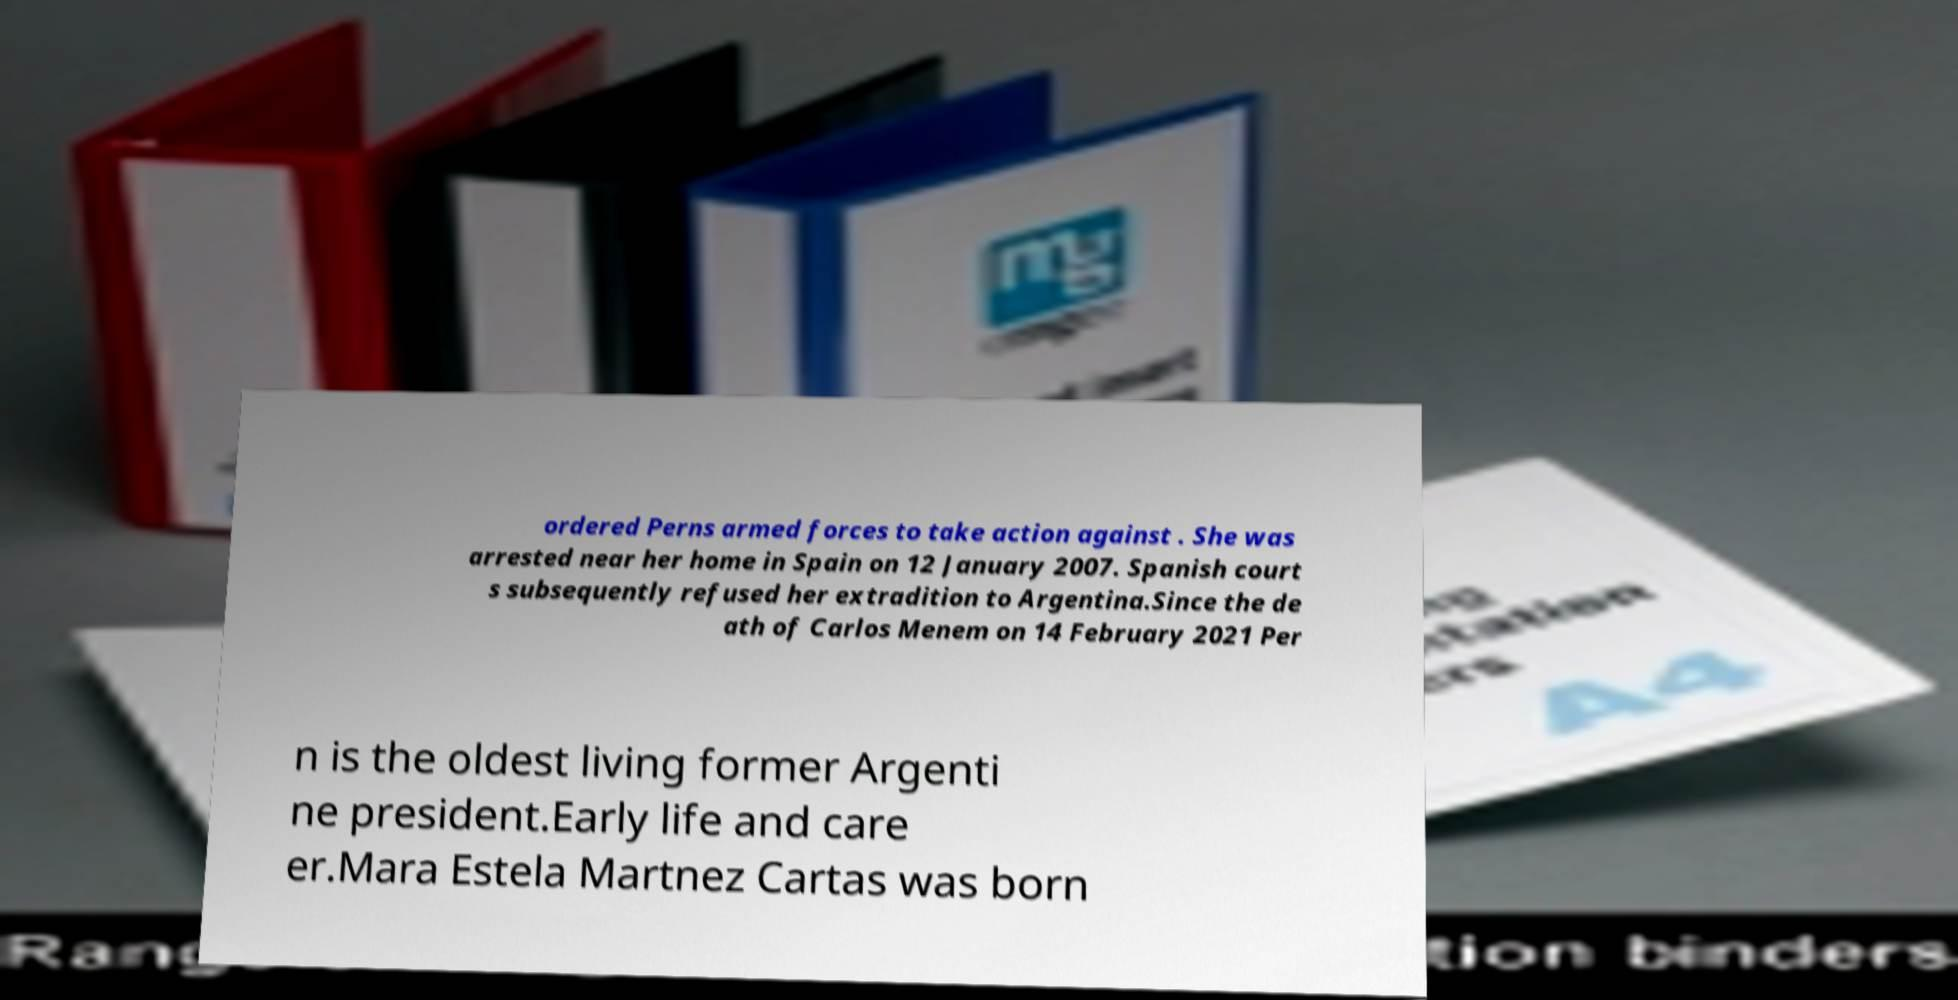For documentation purposes, I need the text within this image transcribed. Could you provide that? ordered Perns armed forces to take action against . She was arrested near her home in Spain on 12 January 2007. Spanish court s subsequently refused her extradition to Argentina.Since the de ath of Carlos Menem on 14 February 2021 Per n is the oldest living former Argenti ne president.Early life and care er.Mara Estela Martnez Cartas was born 